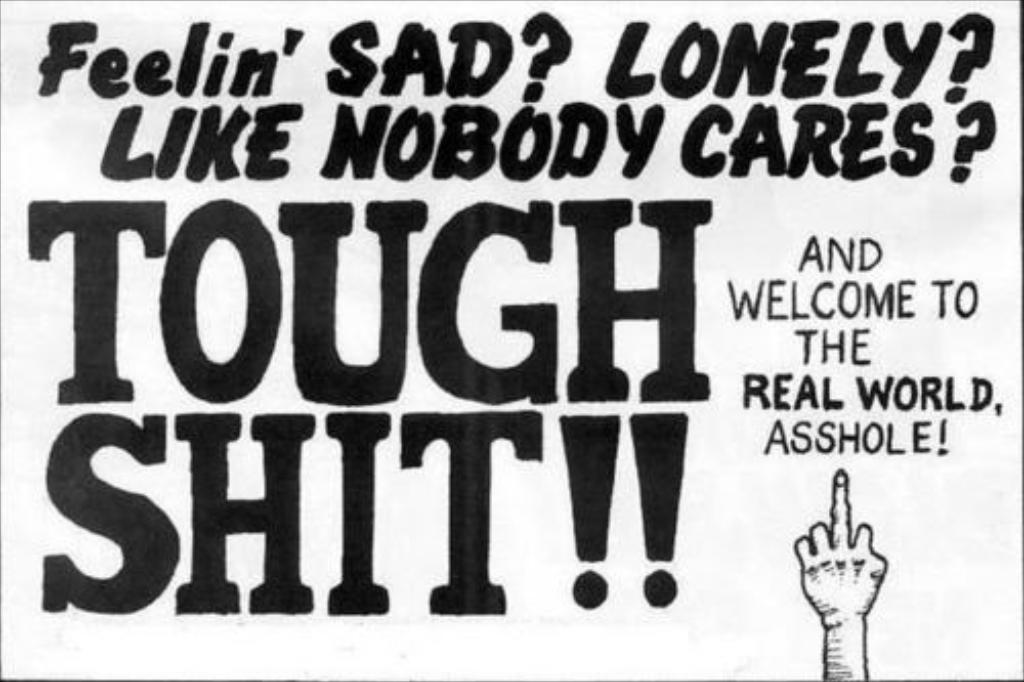<image>
Relay a brief, clear account of the picture shown. A black and white sign that says Feelin' SAD 